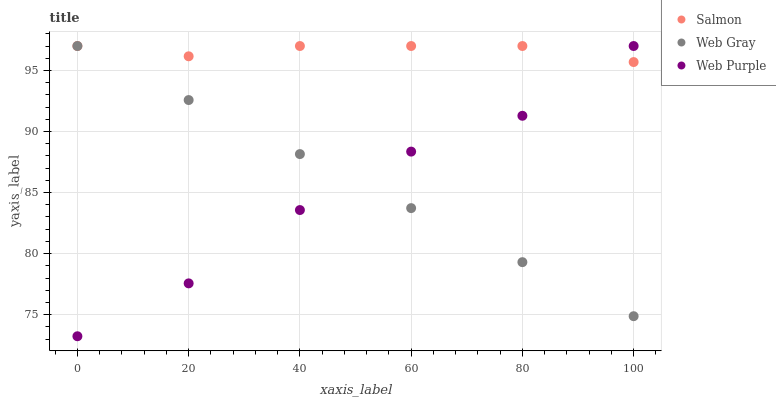Does Web Purple have the minimum area under the curve?
Answer yes or no. Yes. Does Salmon have the maximum area under the curve?
Answer yes or no. Yes. Does Web Gray have the minimum area under the curve?
Answer yes or no. No. Does Web Gray have the maximum area under the curve?
Answer yes or no. No. Is Web Gray the smoothest?
Answer yes or no. Yes. Is Web Purple the roughest?
Answer yes or no. Yes. Is Salmon the smoothest?
Answer yes or no. No. Is Salmon the roughest?
Answer yes or no. No. Does Web Purple have the lowest value?
Answer yes or no. Yes. Does Web Gray have the lowest value?
Answer yes or no. No. Does Salmon have the highest value?
Answer yes or no. Yes. Does Salmon intersect Web Gray?
Answer yes or no. Yes. Is Salmon less than Web Gray?
Answer yes or no. No. Is Salmon greater than Web Gray?
Answer yes or no. No. 